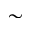<formula> <loc_0><loc_0><loc_500><loc_500>\sim</formula> 